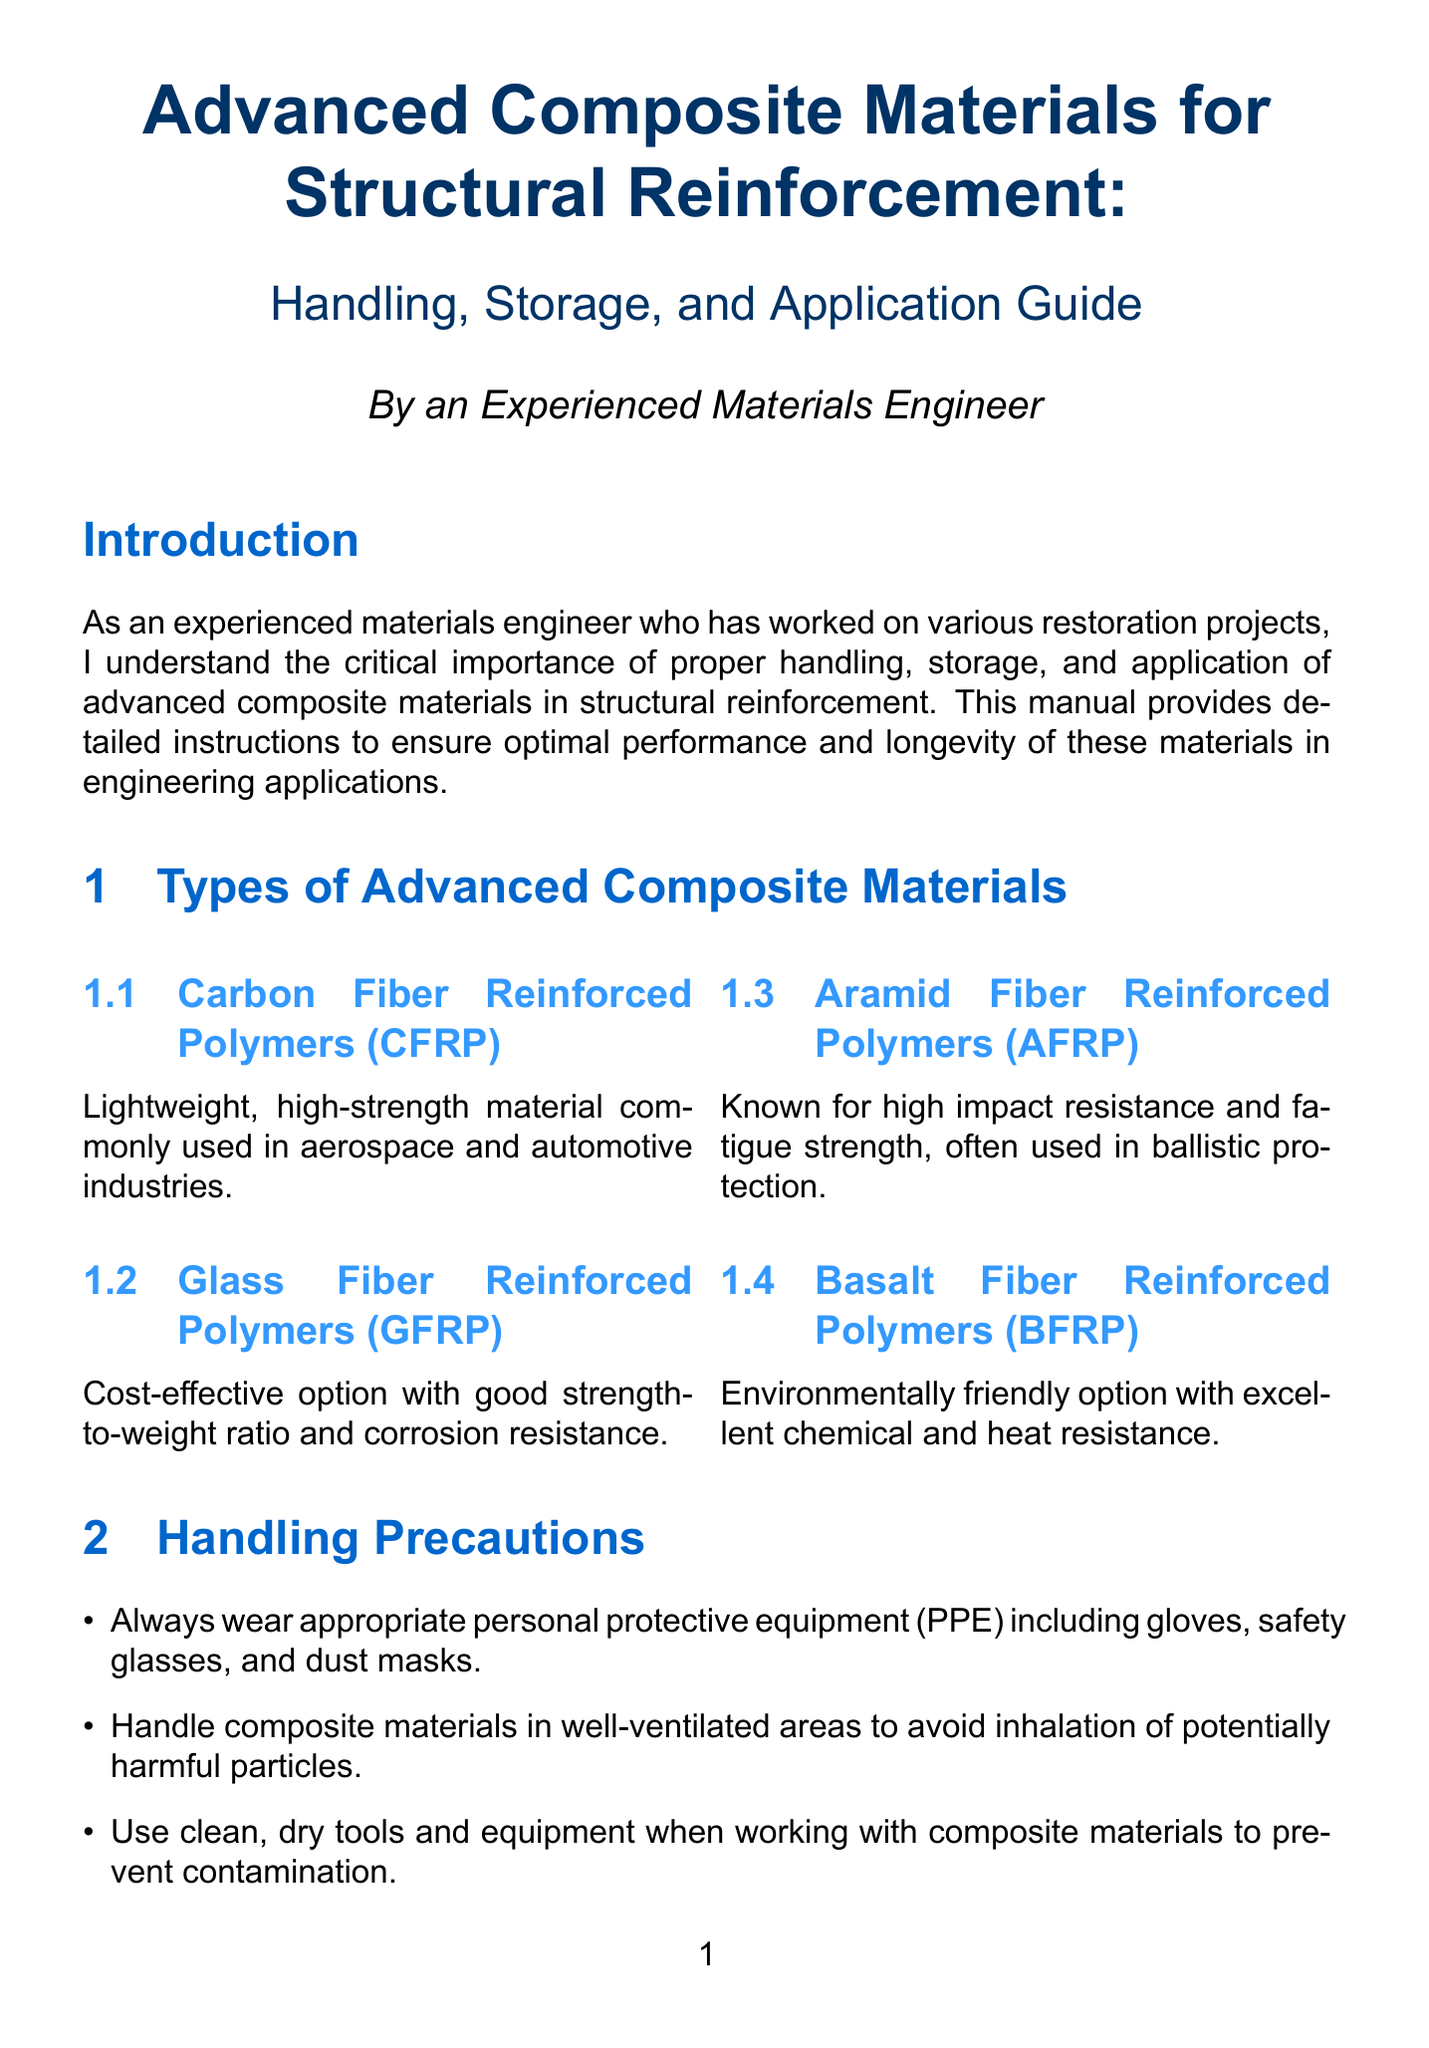What is the title of the manual? The title of the manual is explicitly stated at the beginning of the document.
Answer: Advanced Composite Materials for Structural Reinforcement: Handling, Storage, and Application Guide What is the temperature range for storage of composite materials? The document specifies the controlled temperature range for storage of composite materials.
Answer: 15-25°C What type of fiber is known for high impact resistance? The document provides a list of advanced composite materials, specifying the type known for high impact resistance.
Answer: Aramid Fiber Reinforced Polymers (AFRP) What is the recommended primer application for? The document discusses the significance of primer applications in the surface preparation section.
Answer: Enhance adhesion How should composite fabrics be stored to prevent deformation? The storage guidelines specify the correct storage method for composite fabrics to avoid deformation.
Answer: Horizontally on racks or shelves What is the first step in the Wet Lay-up Method? The manual outlines the first step required in the Wet Lay-up Method for applying composite materials.
Answer: Cut composite fabric to required dimensions What health consideration should personnel review before using materials? The document highlights an important health consideration regarding the use of composite materials.
Answer: Safety Data Sheets (SDS) What method should be used for quality control inspection? The document specifies methods for inspecting bond quality as part of quality control procedures.
Answer: Non-destructive testing methods What equipment is recommended for mixing epoxy resins? The document outlines the appropriate equipment to use when mixing epoxy resins for application.
Answer: Low-speed drill with a mixing paddle 